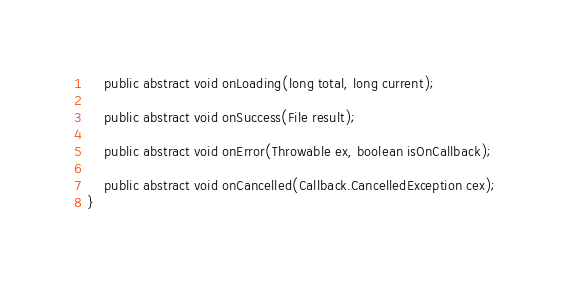Convert code to text. <code><loc_0><loc_0><loc_500><loc_500><_Java_>    public abstract void onLoading(long total, long current);

    public abstract void onSuccess(File result);

    public abstract void onError(Throwable ex, boolean isOnCallback);

    public abstract void onCancelled(Callback.CancelledException cex);
}
</code> 